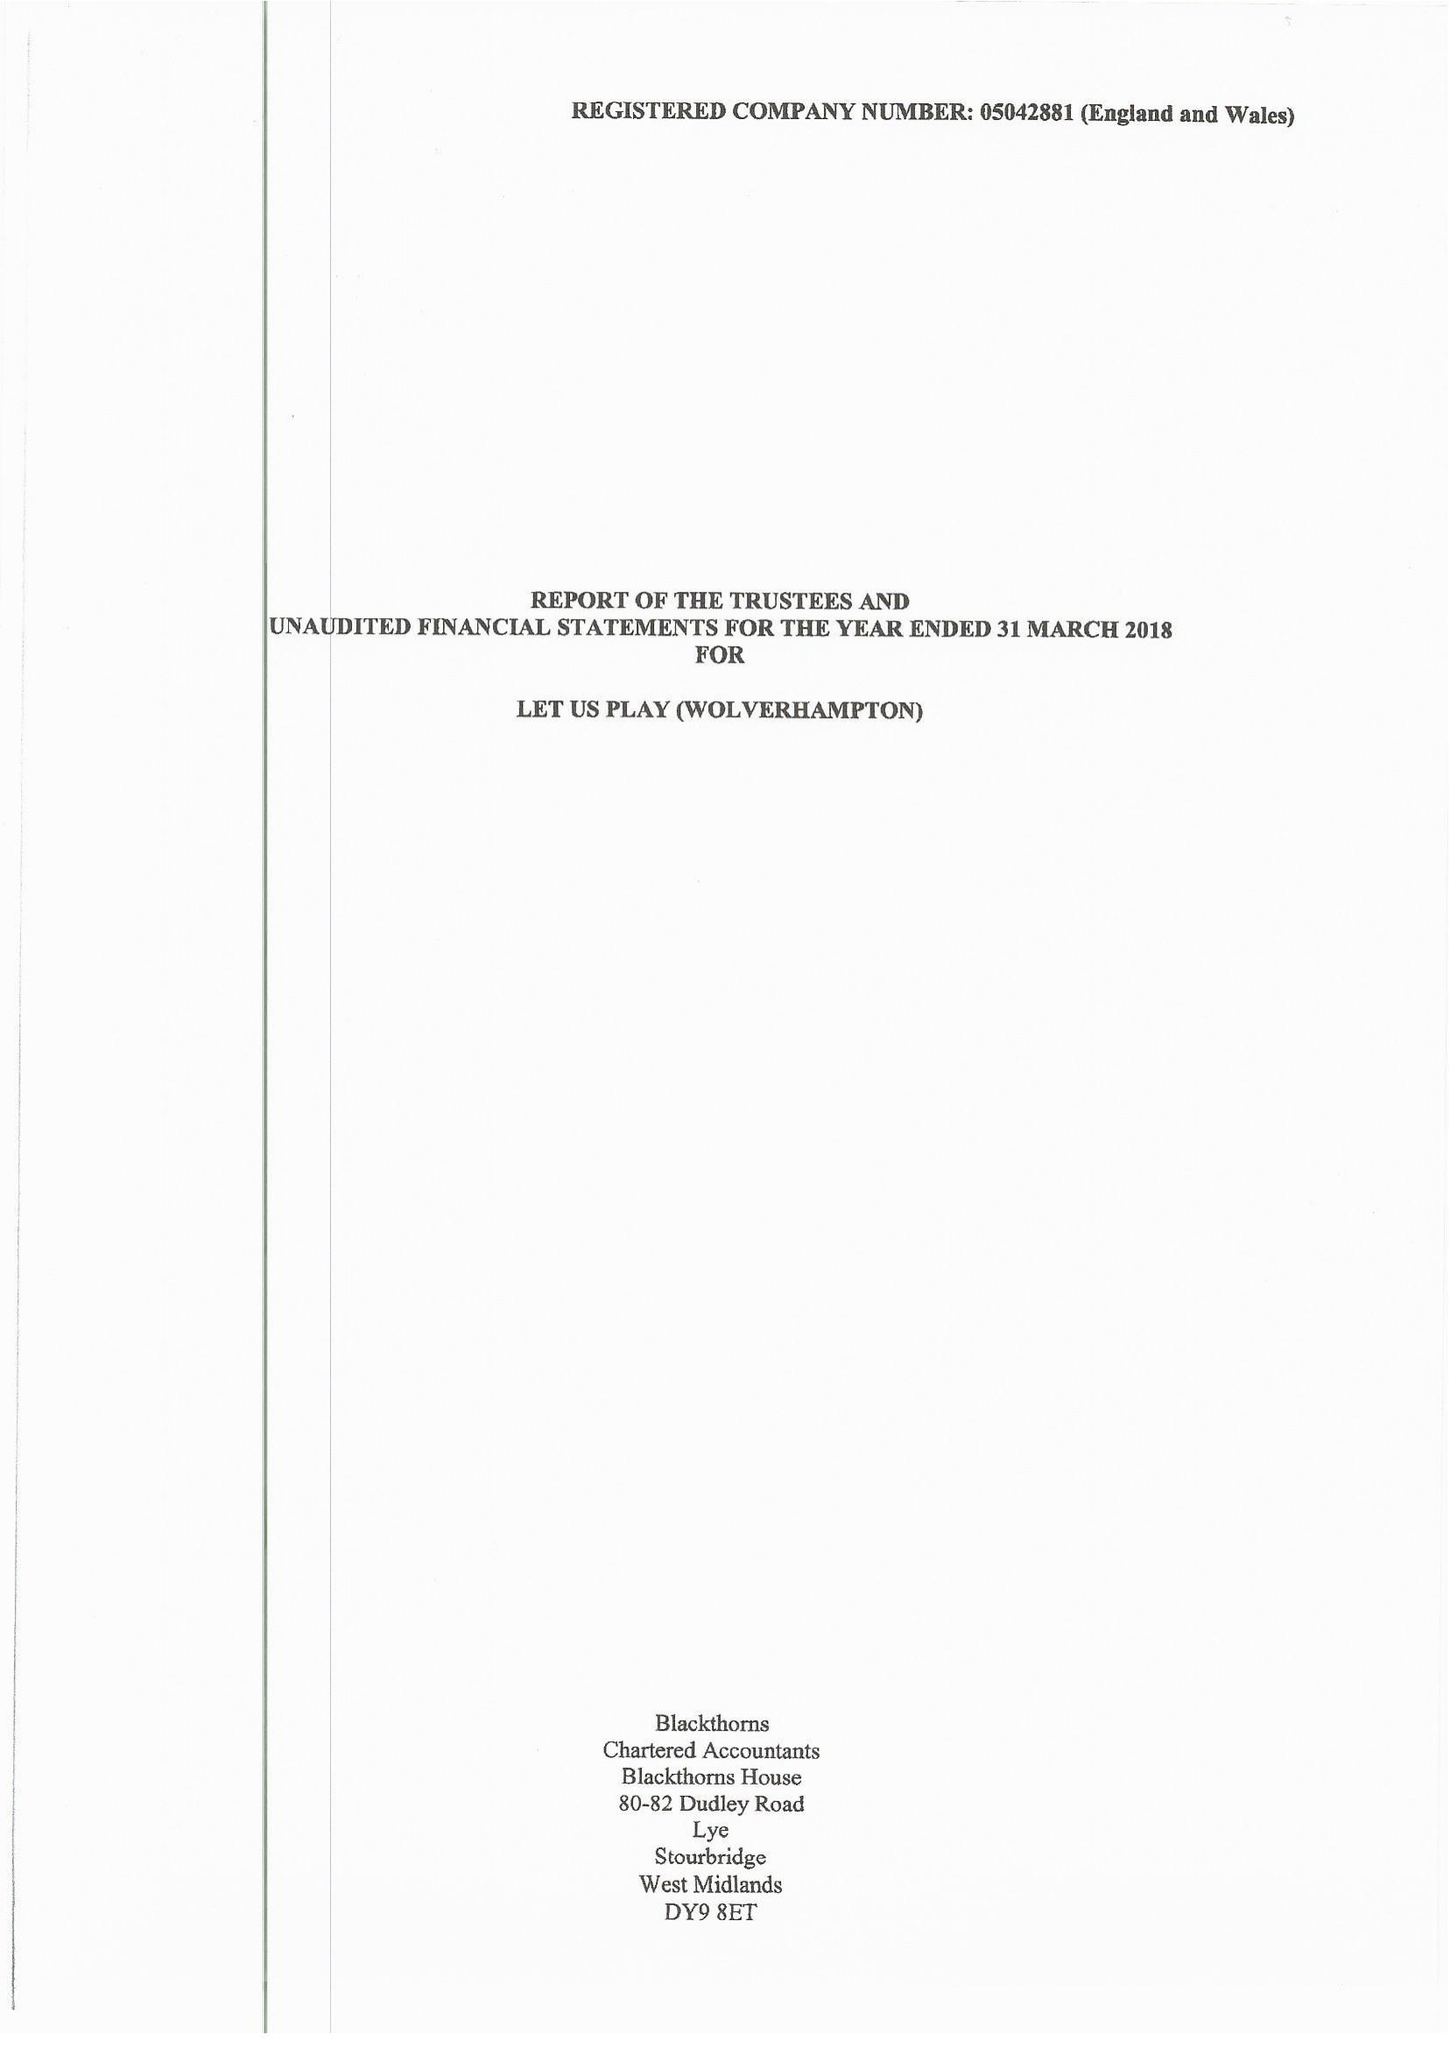What is the value for the charity_number?
Answer the question using a single word or phrase. 1104506 